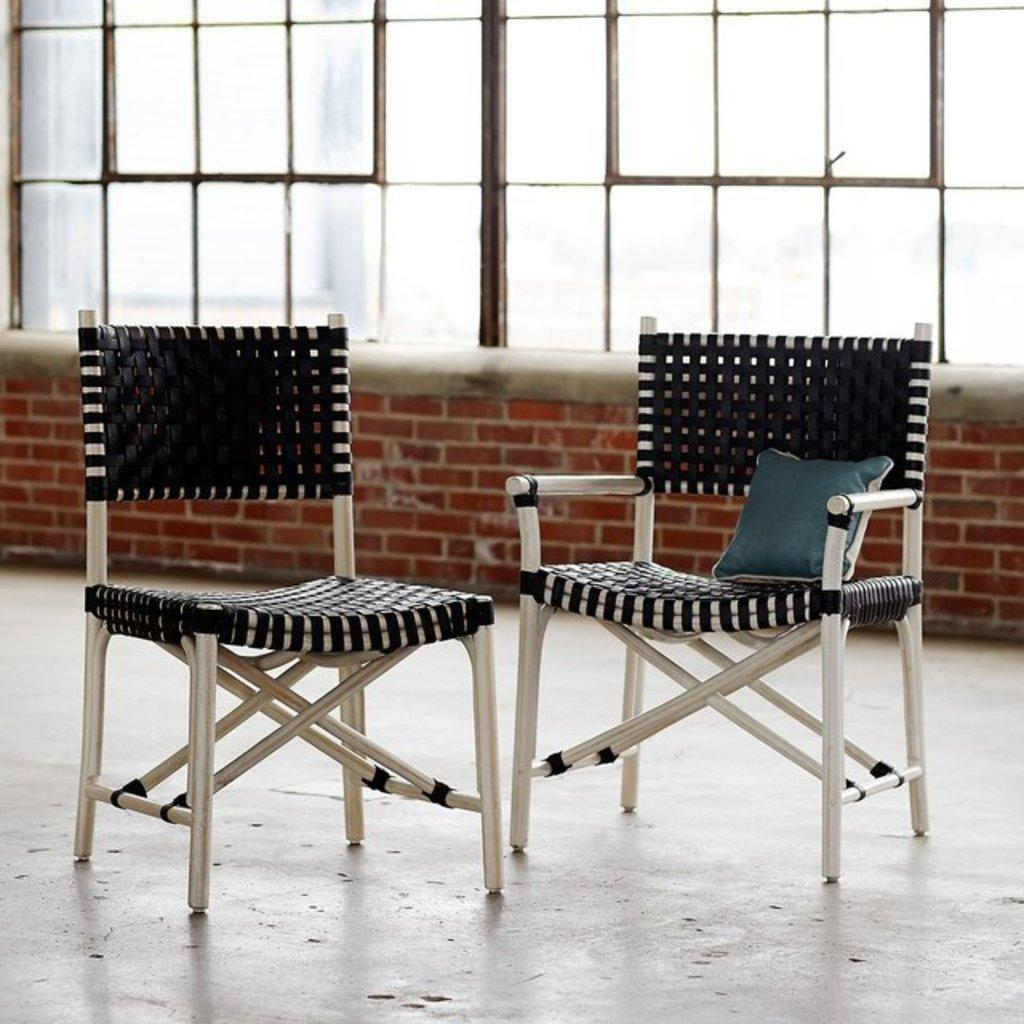What type of furniture is on the ground in the image? There are two chairs on the ground in the image. What type of soft object is in the image? There is a pillow in the image. What can be seen in the background of the image? There is a wall and windows in the background of the image. What type of dinosaurs can be seen in the image? There are no dinosaurs present in the image. What kind of apparatus is being used by the chairs in the image? The chairs are not using any apparatus; they are simply on the ground. 